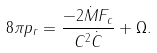<formula> <loc_0><loc_0><loc_500><loc_500>8 \pi p _ { r } = \frac { - 2 \dot { M } F _ { c } } { C ^ { 2 } \dot { C } } + \Omega .</formula> 